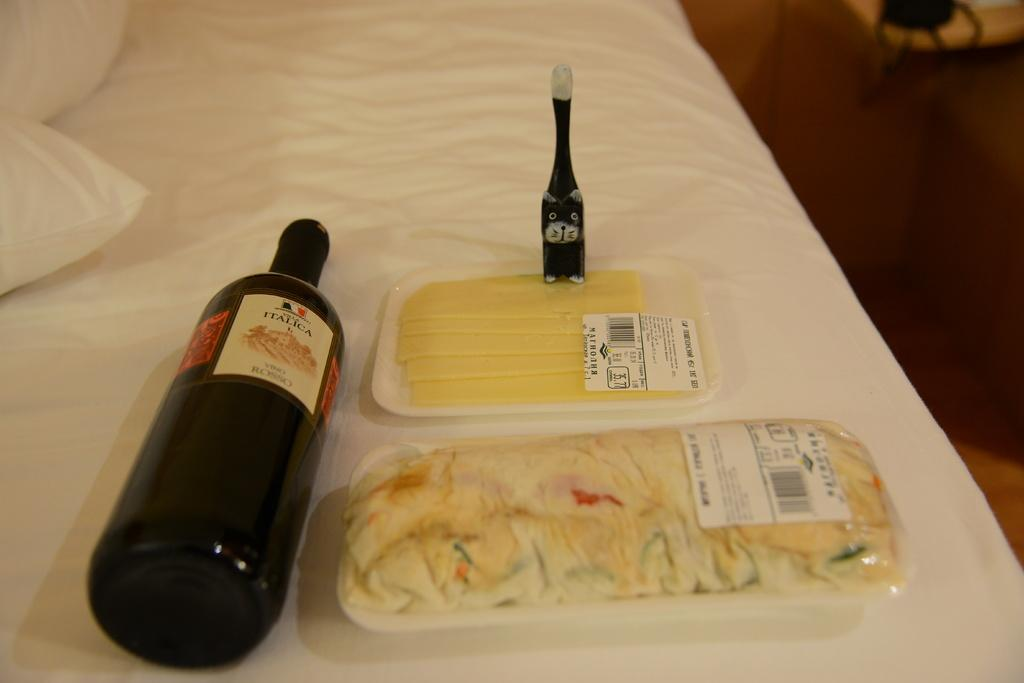<image>
Relay a brief, clear account of the picture shown. A bottle of red wine lying on its side bearing the word Italica. 